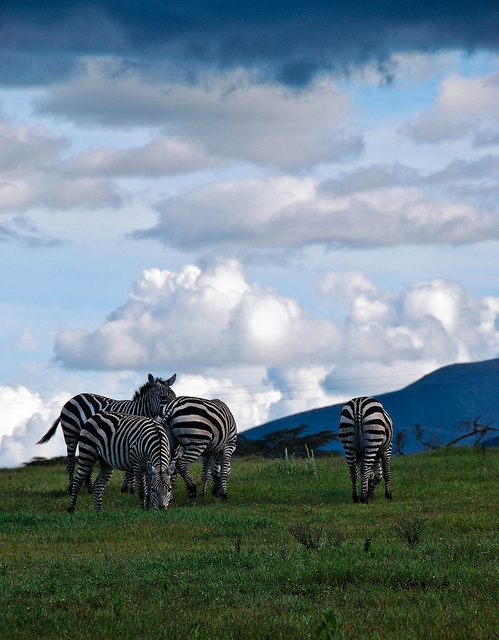Describe the objects in this image and their specific colors. I can see zebra in navy, black, gray, darkgray, and blue tones, zebra in navy, black, gray, darkgray, and blue tones, zebra in navy, black, gray, darkgray, and darkblue tones, and zebra in navy, black, gray, and blue tones in this image. 